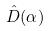<formula> <loc_0><loc_0><loc_500><loc_500>\hat { D } ( \alpha )</formula> 